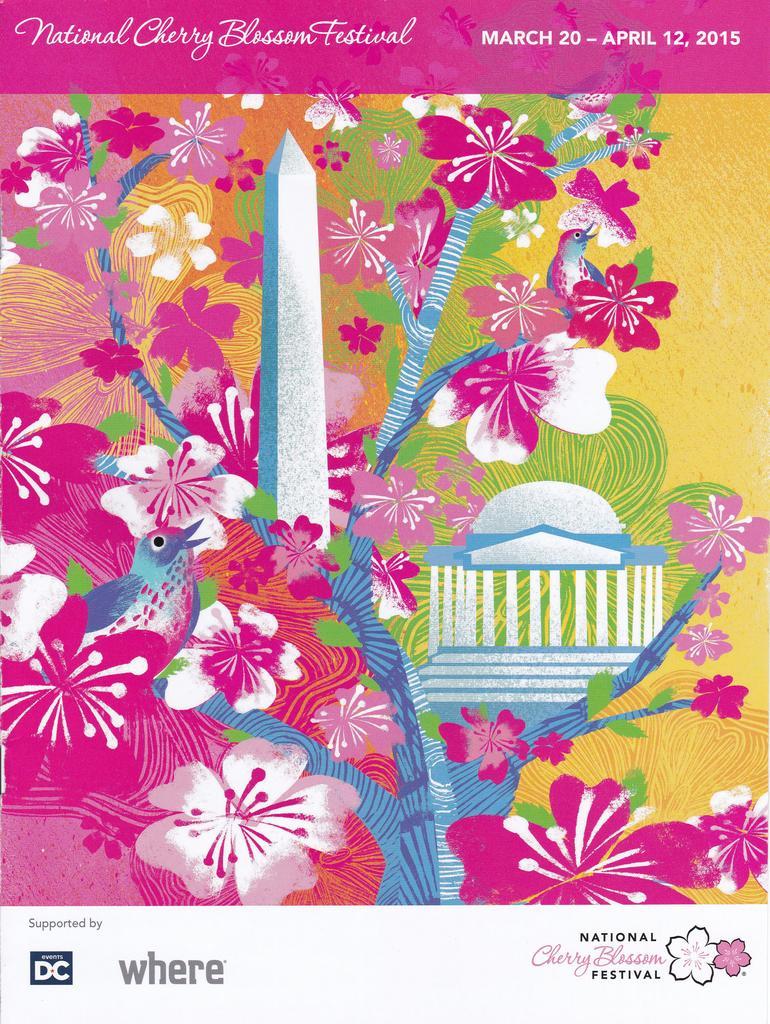How would you summarize this image in a sentence or two? This image consists of a poster with many images of flowers, a bird and there is a text on it. 